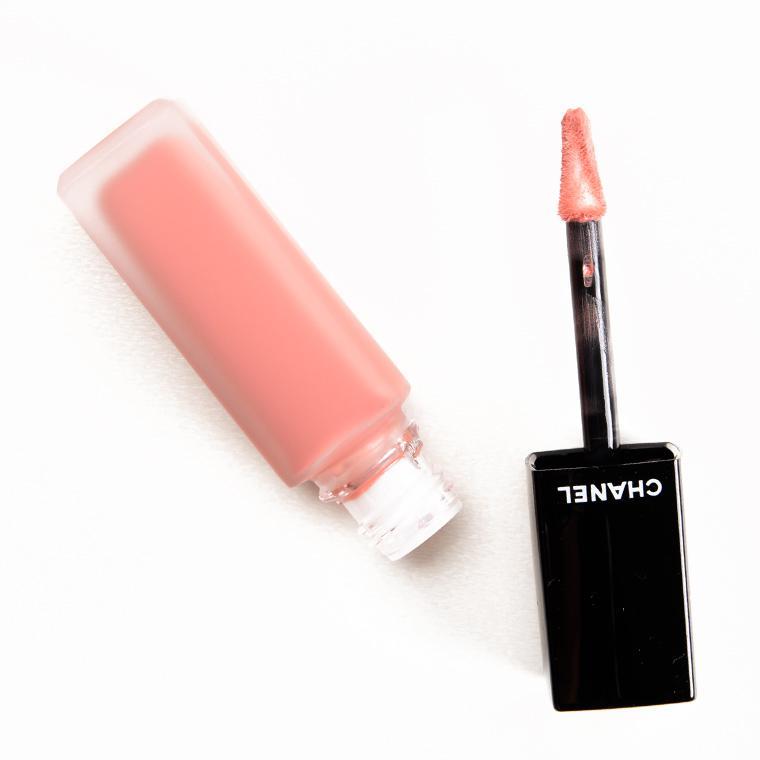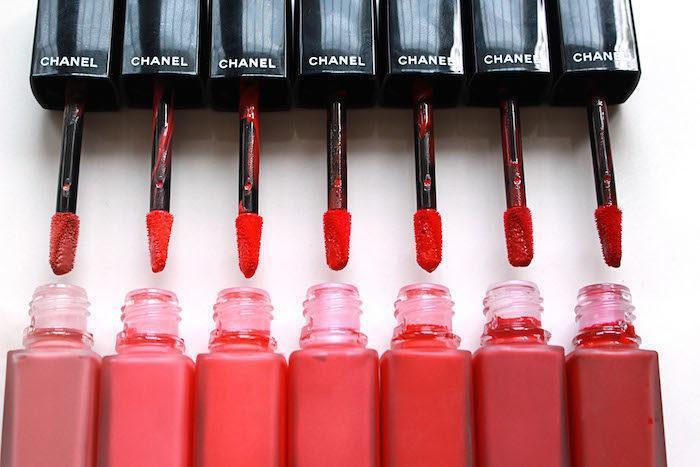The first image is the image on the left, the second image is the image on the right. For the images displayed, is the sentence "lipsticks are shown with the lids off" factually correct? Answer yes or no. Yes. The first image is the image on the left, the second image is the image on the right. Assess this claim about the two images: "An image shows exactly one lip makeup item, displayed with its cap removed.". Correct or not? Answer yes or no. Yes. 